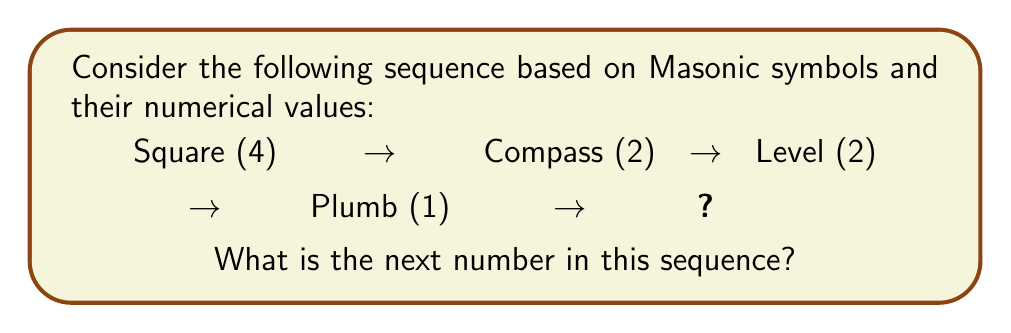Give your solution to this math problem. To solve this sequence, we need to understand the pattern based on Masonic symbols and their associated numerical values. Let's break it down step-by-step:

1. Square (4): In Freemasonry, the square represents morality and has 4 sides.

2. Compass (2): The compass symbolizes virtue and has 2 arms.

3. Level (2): The level represents equality and has 2 main parts (the horizontal bar and the plumb).

4. Plumb (1): The plumb represents uprightness and has 1 vertical line.

5. To find the next number, we need to identify the pattern:
   $$4 \rightarrow 2 \rightarrow 2 \rightarrow 1$$

   The pattern appears to be decreasing, with a repeating 2 in the middle.

6. Following this pattern, the next number should be half of the previous one:
   $$\frac{1}{2} = 0.5$$

7. In Masonic symbolism, the number 0.5 or ½ is significant as it represents balance and duality, often associated with the checkered flooring of the Lodge (alternating black and white squares).

Therefore, the next number in the sequence is 0.5, which can be represented by the Masonic symbol of the checkered flooring or the point within a circle, symbolizing the individual Mason (point) within the boundary of his duty to God and man (circle).
Answer: 0.5 